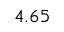Convert formula to latex. <formula><loc_0><loc_0><loc_500><loc_500>4 . 6 5</formula> 